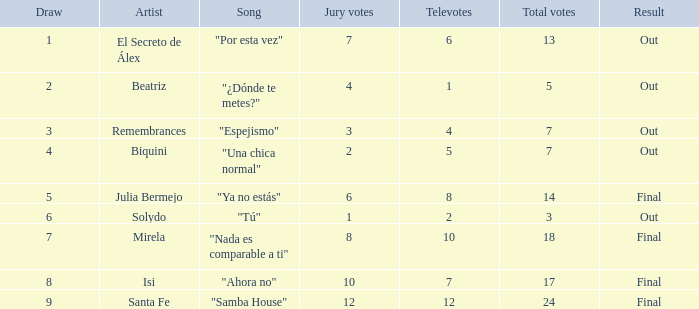State the count of tunes related to julia bermejo. 1.0. 